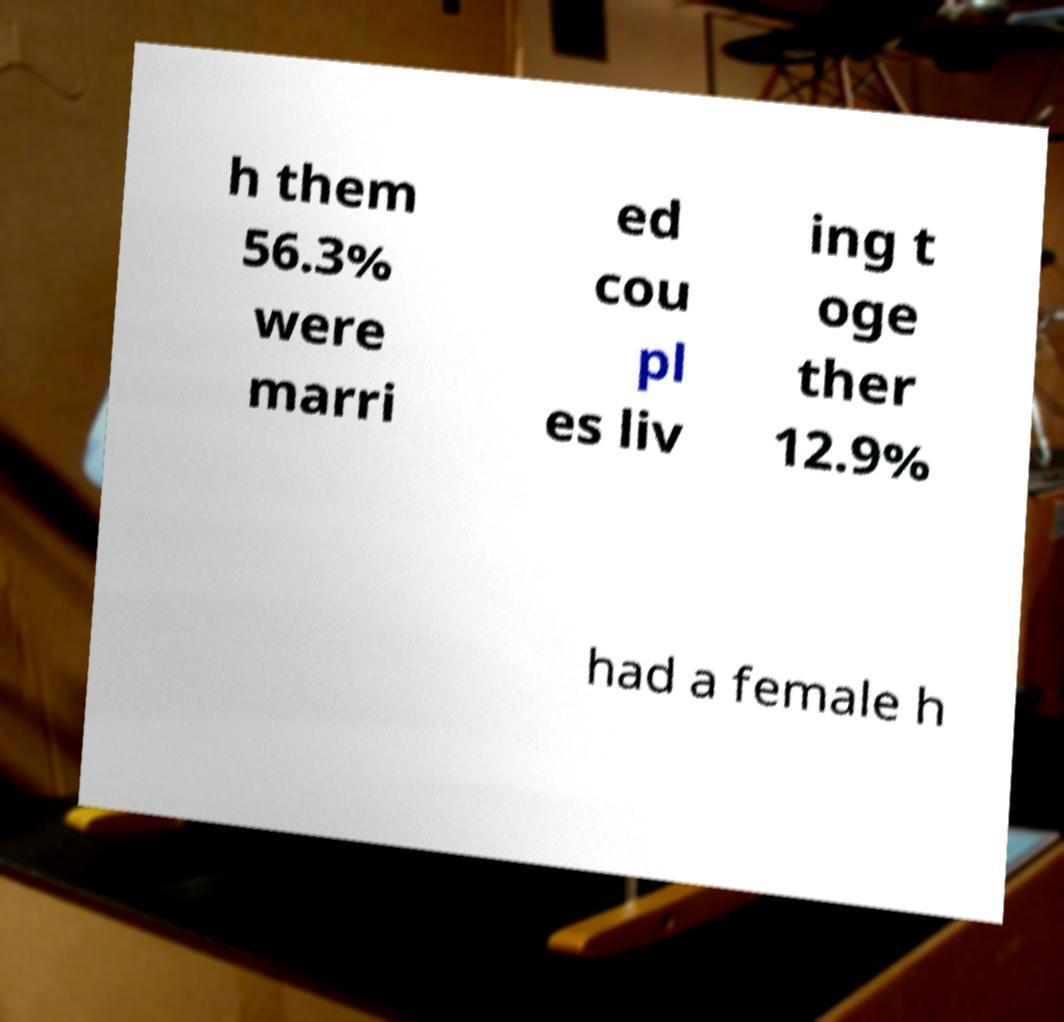There's text embedded in this image that I need extracted. Can you transcribe it verbatim? h them 56.3% were marri ed cou pl es liv ing t oge ther 12.9% had a female h 